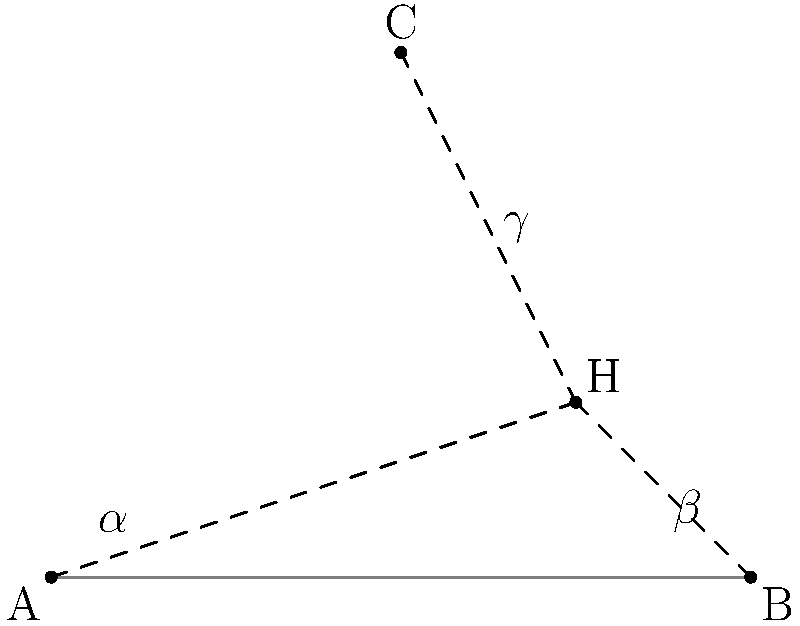In the diagram, points A, B, and C represent key conservation points, while H represents the location of the proposed high-rise. If the angles formed by the sight lines from A, B, and C to H are $\alpha$, $\beta$, and $\gamma$ respectively, which mathematical relationship would be most useful in determining the maximum allowable height of the high-rise to minimize visual impact from all three conservation points? To determine the maximum allowable height of the high-rise while minimizing visual impact from all three conservation points, we need to consider the following steps:

1. Recognize that the sight lines from A, B, and C to H form three triangles: AHB, BHC, and AHC.

2. The angles $\alpha$, $\beta$, and $\gamma$ are the angles at which the high-rise is viewed from each conservation point.

3. The smaller these angles are, the less visible the high-rise will be from each point.

4. To minimize the visual impact from all points simultaneously, we need to consider the largest of these angles, as it represents the "worst-case" visibility.

5. Mathematically, this can be expressed as:
   $\max(\alpha, \beta, \gamma)$

6. The goal would be to minimize this maximum angle.

7. In trigonometry, the tangent of an angle in a right-angled triangle represents the ratio of the opposite side to the adjacent side.

8. If we consider the height of the high-rise as the opposite side and the distance from each conservation point as the adjacent side, we can use the arctangent function to relate the angle to the height:
   $\text{angle} = \arctan(\frac{\text{height}}{\text{distance}})$

9. Therefore, the relationship we're looking for is:
   $\min(\max(\arctan(\frac{h}{d_A}), \arctan(\frac{h}{d_B}), \arctan(\frac{h}{d_C})))$

Where $h$ is the height of the high-rise, and $d_A$, $d_B$, and $d_C$ are the distances from points A, B, and C to H, respectively.
Answer: $\min(\max(\arctan(\frac{h}{d_A}), \arctan(\frac{h}{d_B}), \arctan(\frac{h}{d_C})))$ 